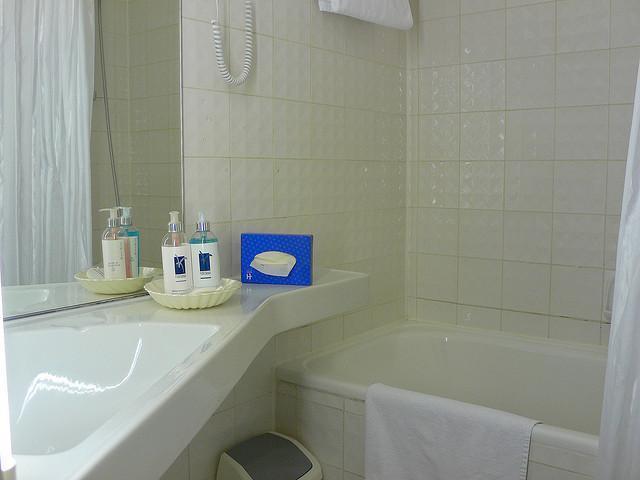How many bottles are sitting on the counter?
Give a very brief answer. 2. How many boats can you see?
Give a very brief answer. 0. 